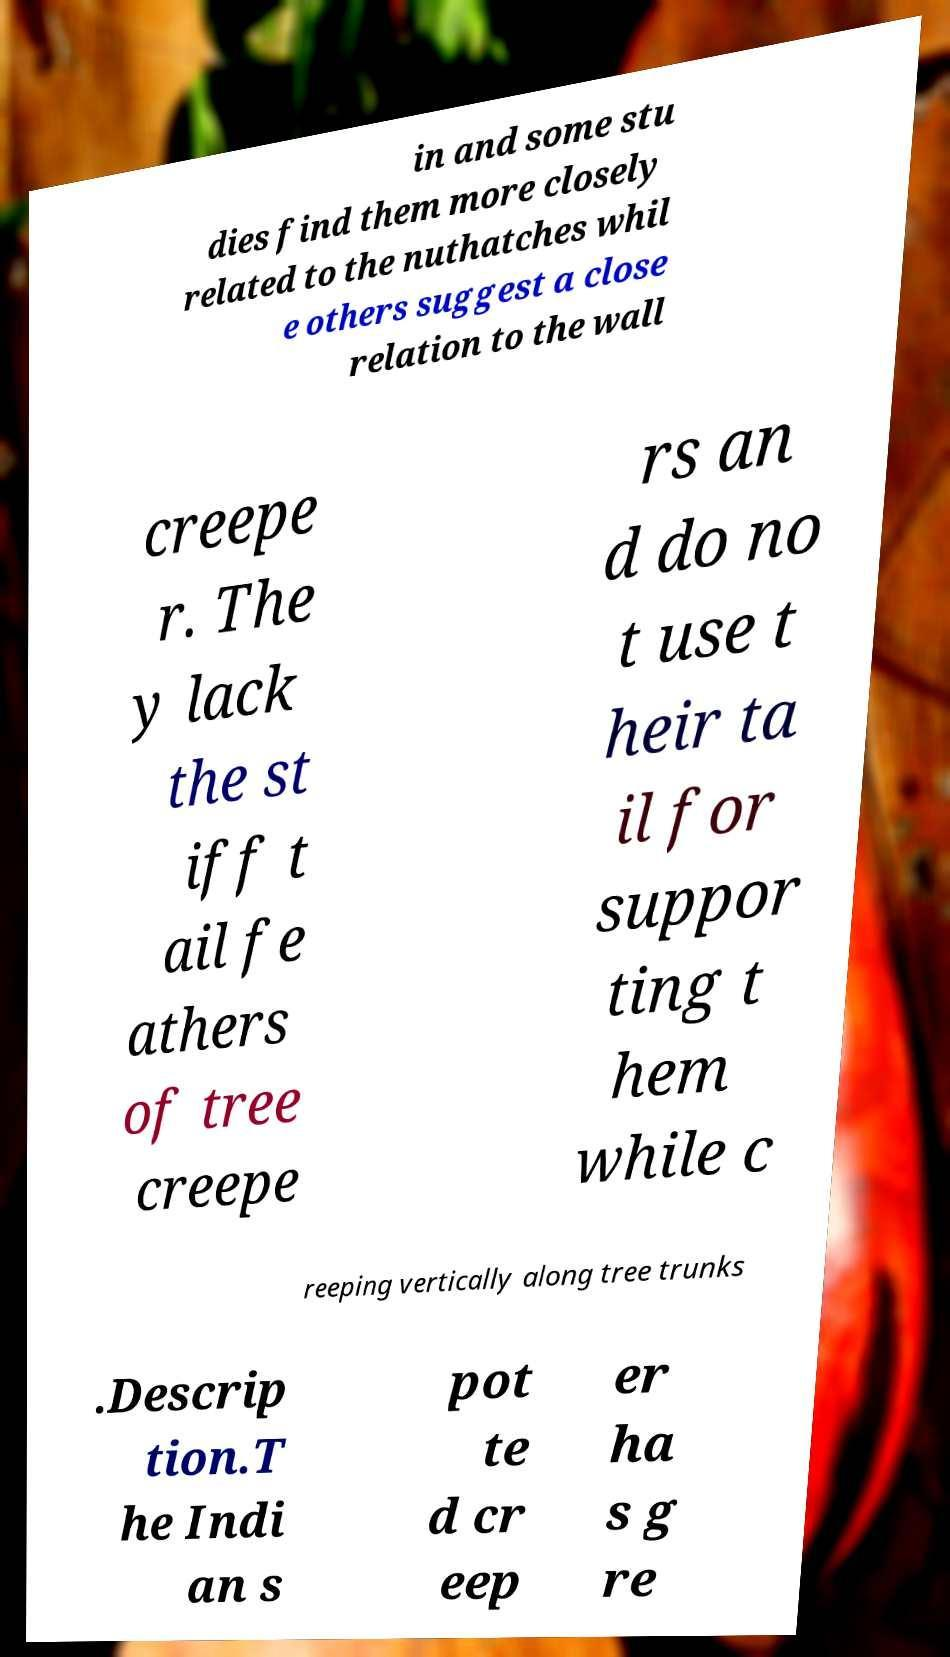Could you extract and type out the text from this image? in and some stu dies find them more closely related to the nuthatches whil e others suggest a close relation to the wall creepe r. The y lack the st iff t ail fe athers of tree creepe rs an d do no t use t heir ta il for suppor ting t hem while c reeping vertically along tree trunks .Descrip tion.T he Indi an s pot te d cr eep er ha s g re 